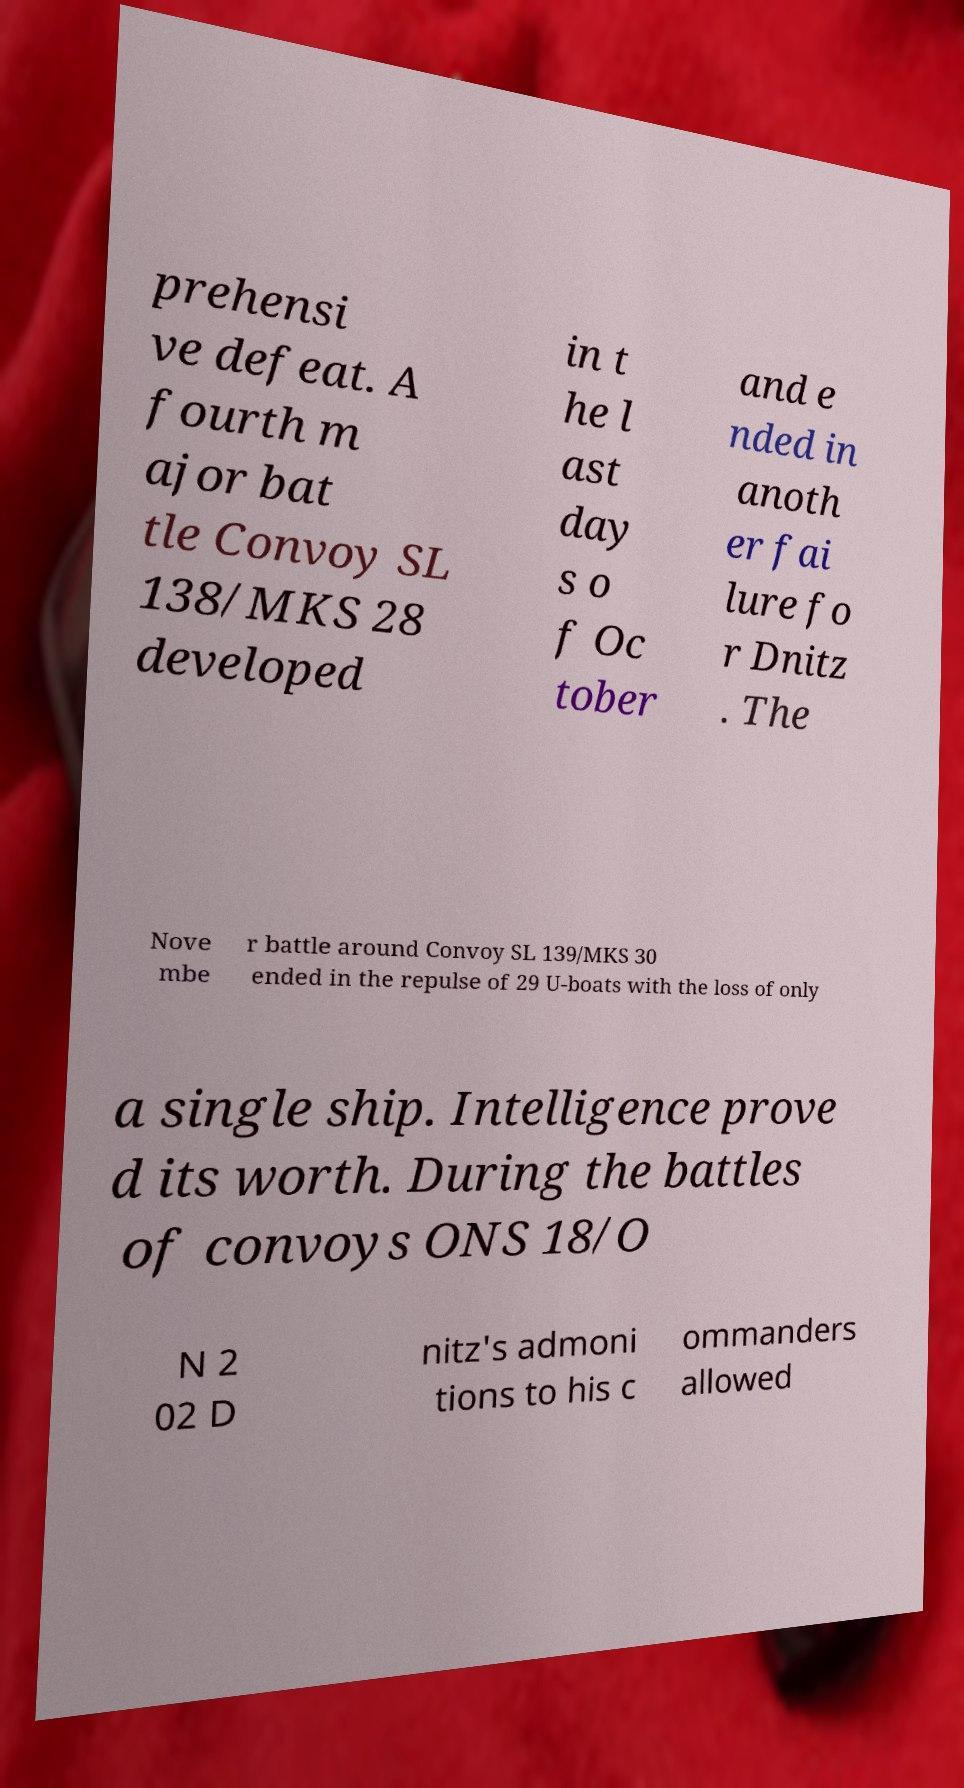Please identify and transcribe the text found in this image. prehensi ve defeat. A fourth m ajor bat tle Convoy SL 138/MKS 28 developed in t he l ast day s o f Oc tober and e nded in anoth er fai lure fo r Dnitz . The Nove mbe r battle around Convoy SL 139/MKS 30 ended in the repulse of 29 U-boats with the loss of only a single ship. Intelligence prove d its worth. During the battles of convoys ONS 18/O N 2 02 D nitz's admoni tions to his c ommanders allowed 